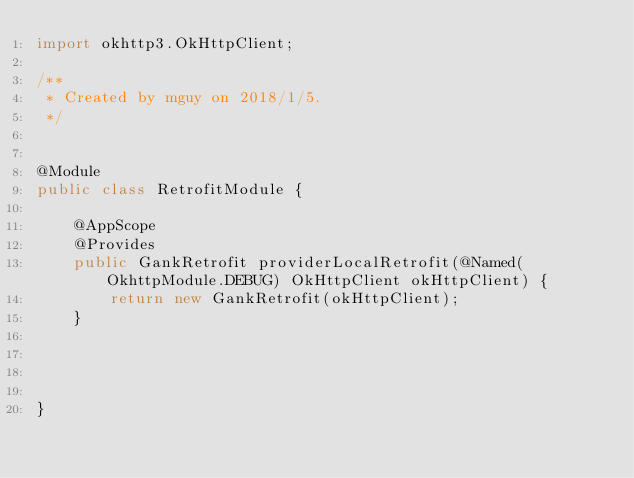Convert code to text. <code><loc_0><loc_0><loc_500><loc_500><_Java_>import okhttp3.OkHttpClient;

/**
 * Created by mguy on 2018/1/5.
 */


@Module
public class RetrofitModule {

    @AppScope
    @Provides
    public GankRetrofit providerLocalRetrofit(@Named(OkhttpModule.DEBUG) OkHttpClient okHttpClient) {
        return new GankRetrofit(okHttpClient);
    }




}


</code> 